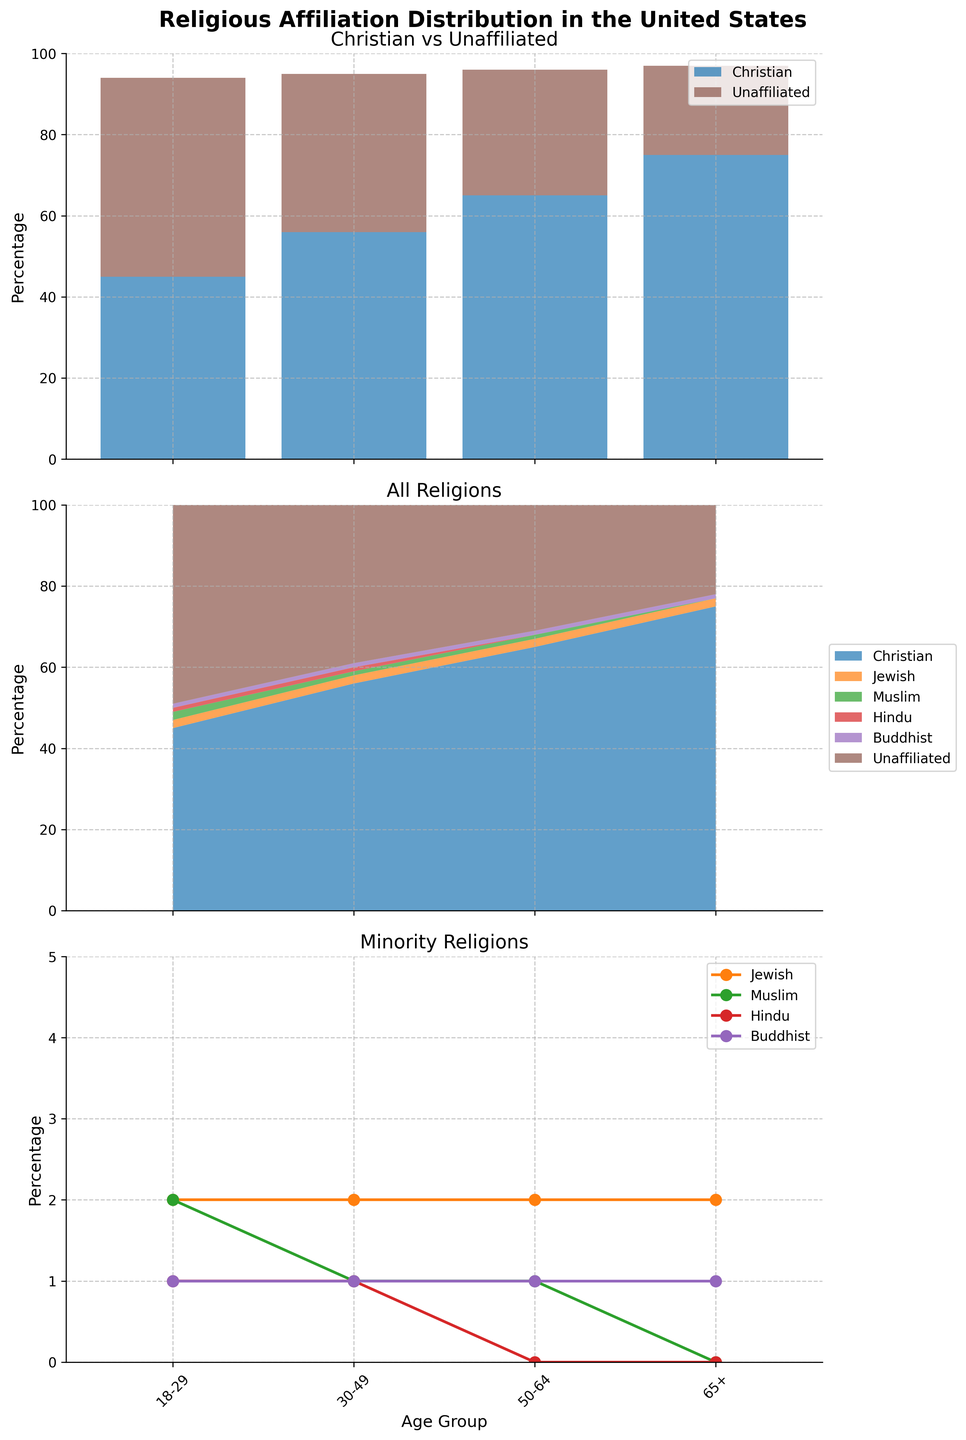What is the title of the overall figure? The title is written at the top of the figure and states "Religious Affiliation Distribution in the United States".
Answer: Religious Affiliation Distribution in the United States What are the age groups depicted in the figure? The x-axis labels of the subplots show the age groups, which are "18-29", "30-49", "50-64", and "65+".
Answer: 18-29, 30-49, 50-64, 65+ Which group shows the highest percentage of Christians? In the first subplot, the bars for Christians are tallest for the "65+" age group.
Answer: 65+ What religion consistently shows a 2% distribution across all age groups? The legend and the lines in the minority religions subplot show that the Jewish religion has a consistent 2% distribution across all age groups.
Answer: Jewish How does the percentage of the Unaﬃliated category change as age increases? In the first subplot, the bar for the Unaﬃliated category decreases in height as the age groups go from 18-29 to 65+. The percentages are 49%, 39%, 31%, and 22%.
Answer: It decreases Which age group has the least religious unidentified factions combined? In the stacked area chart (second subplot), the sum of the minority religions for the "65+" age group is the smallest, which is 3%.
Answer: 65+ What is the difference in the percentage of Christians between the age groups 18-29 and 50-64? The percentage of Christians in the 18-29 age group is 45%, and in the 50-64 age group is 65%. The difference is 65% - 45%.
Answer: 20% Which subgroup has the smallest change across age groups? The line chart (third subplot) shows that the Muslim religion remains almost constant at 1%/2% across all age groups.
Answer: Muslim How does the distribution of Christians and Unaﬃliated compare in the 30-49 age group? In the first subplot, Christians have a higher percentage (56%) than the Unaﬃliated (39%) in the 30-49 age group. The difference can be seen in the height of the stacked bars.
Answer: Christians are higher What is the combined percentage of Christian, Jewish, and Muslim followers in the age group 65+? From the stacked area chart, in the age group 65+, the percentages are Christian (75%), Jewish (2%), and Muslim (0%). Adding them gives 75% + 2% + 0%.
Answer: 77% 